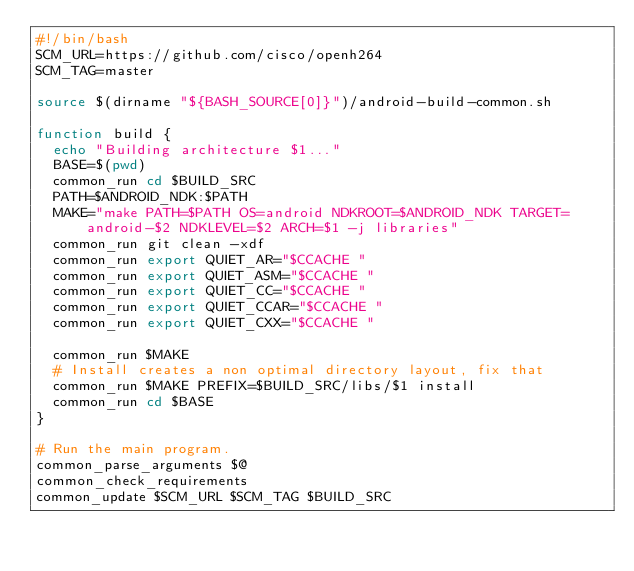<code> <loc_0><loc_0><loc_500><loc_500><_Bash_>#!/bin/bash
SCM_URL=https://github.com/cisco/openh264
SCM_TAG=master

source $(dirname "${BASH_SOURCE[0]}")/android-build-common.sh

function build {
	echo "Building architecture $1..."
	BASE=$(pwd)
	common_run cd $BUILD_SRC
	PATH=$ANDROID_NDK:$PATH
	MAKE="make PATH=$PATH OS=android NDKROOT=$ANDROID_NDK TARGET=android-$2 NDKLEVEL=$2 ARCH=$1 -j libraries"
	common_run git clean -xdf
	common_run export QUIET_AR="$CCACHE "
	common_run export QUIET_ASM="$CCACHE "
	common_run export QUIET_CC="$CCACHE "
	common_run export QUIET_CCAR="$CCACHE "
	common_run export QUIET_CXX="$CCACHE "

	common_run $MAKE
	# Install creates a non optimal directory layout, fix that
	common_run $MAKE PREFIX=$BUILD_SRC/libs/$1 install
	common_run cd $BASE
}

# Run the main program.
common_parse_arguments $@
common_check_requirements
common_update $SCM_URL $SCM_TAG $BUILD_SRC</code> 